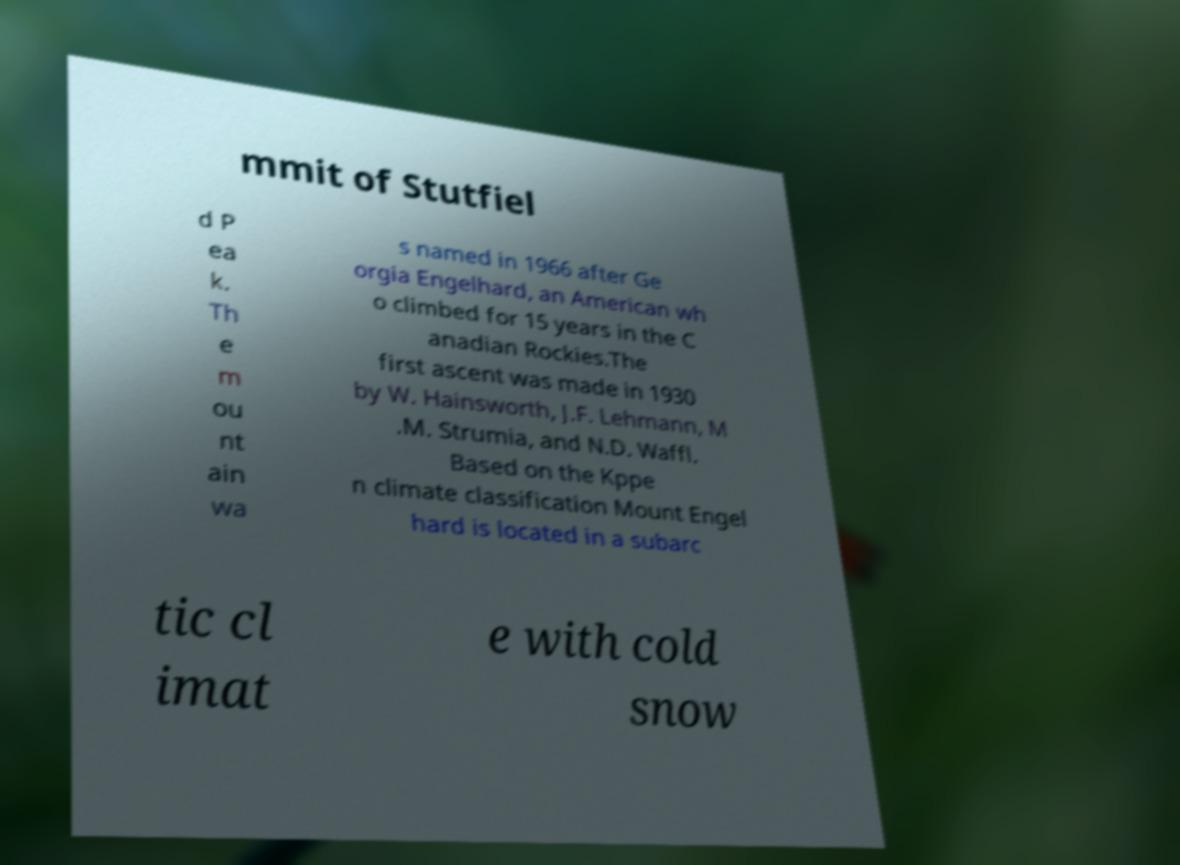For documentation purposes, I need the text within this image transcribed. Could you provide that? mmit of Stutfiel d P ea k. Th e m ou nt ain wa s named in 1966 after Ge orgia Engelhard, an American wh o climbed for 15 years in the C anadian Rockies.The first ascent was made in 1930 by W. Hainsworth, J.F. Lehmann, M .M. Strumia, and N.D. Waffl. Based on the Kppe n climate classification Mount Engel hard is located in a subarc tic cl imat e with cold snow 